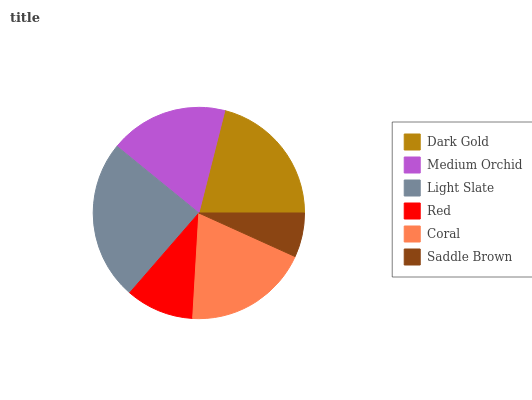Is Saddle Brown the minimum?
Answer yes or no. Yes. Is Light Slate the maximum?
Answer yes or no. Yes. Is Medium Orchid the minimum?
Answer yes or no. No. Is Medium Orchid the maximum?
Answer yes or no. No. Is Dark Gold greater than Medium Orchid?
Answer yes or no. Yes. Is Medium Orchid less than Dark Gold?
Answer yes or no. Yes. Is Medium Orchid greater than Dark Gold?
Answer yes or no. No. Is Dark Gold less than Medium Orchid?
Answer yes or no. No. Is Coral the high median?
Answer yes or no. Yes. Is Medium Orchid the low median?
Answer yes or no. Yes. Is Dark Gold the high median?
Answer yes or no. No. Is Dark Gold the low median?
Answer yes or no. No. 